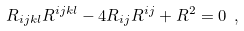Convert formula to latex. <formula><loc_0><loc_0><loc_500><loc_500>R _ { i j k l } R ^ { i j k l } - 4 R _ { i j } R ^ { i j } + R ^ { 2 } = 0 \ ,</formula> 